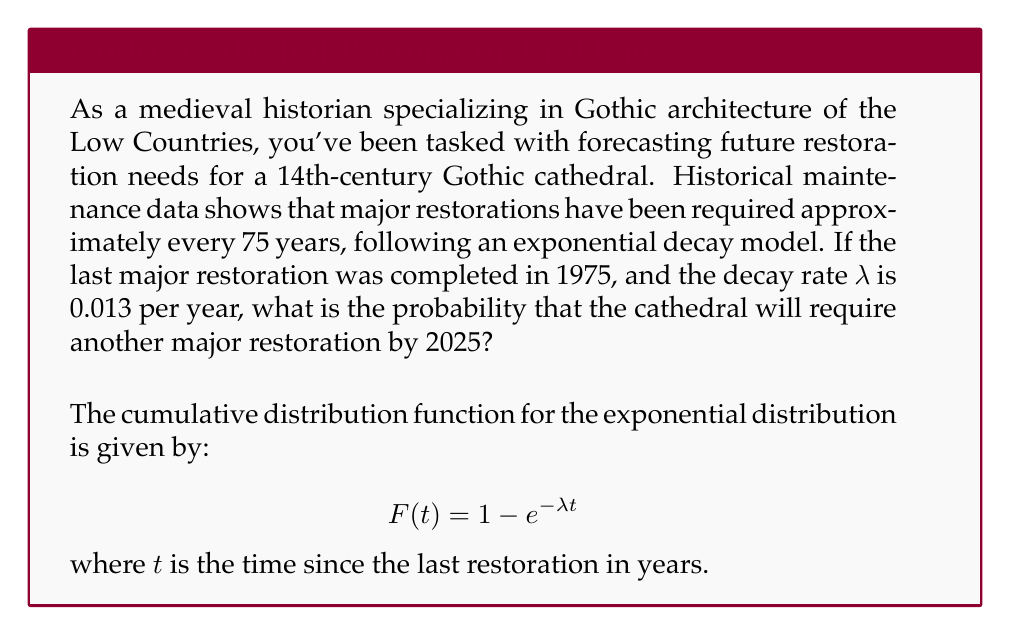What is the answer to this math problem? To solve this problem, we'll follow these steps:

1. Identify the given information:
   - Last major restoration: 1975
   - Current year for prediction: 2025
   - Decay rate (λ): 0.013 per year

2. Calculate the time elapsed since the last restoration:
   $t = 2025 - 1975 = 50$ years

3. Apply the cumulative distribution function:
   $F(t) = 1 - e^{-λt}$
   
   Substituting the values:
   $F(50) = 1 - e^{-0.013 * 50}$

4. Calculate the result:
   $F(50) = 1 - e^{-0.65}$
   $F(50) = 1 - 0.522$
   $F(50) = 0.478$

5. Convert to percentage:
   $0.478 * 100 = 47.8\%$

The probability that the cathedral will require another major restoration by 2025 is approximately 47.8%.
Answer: 47.8% 